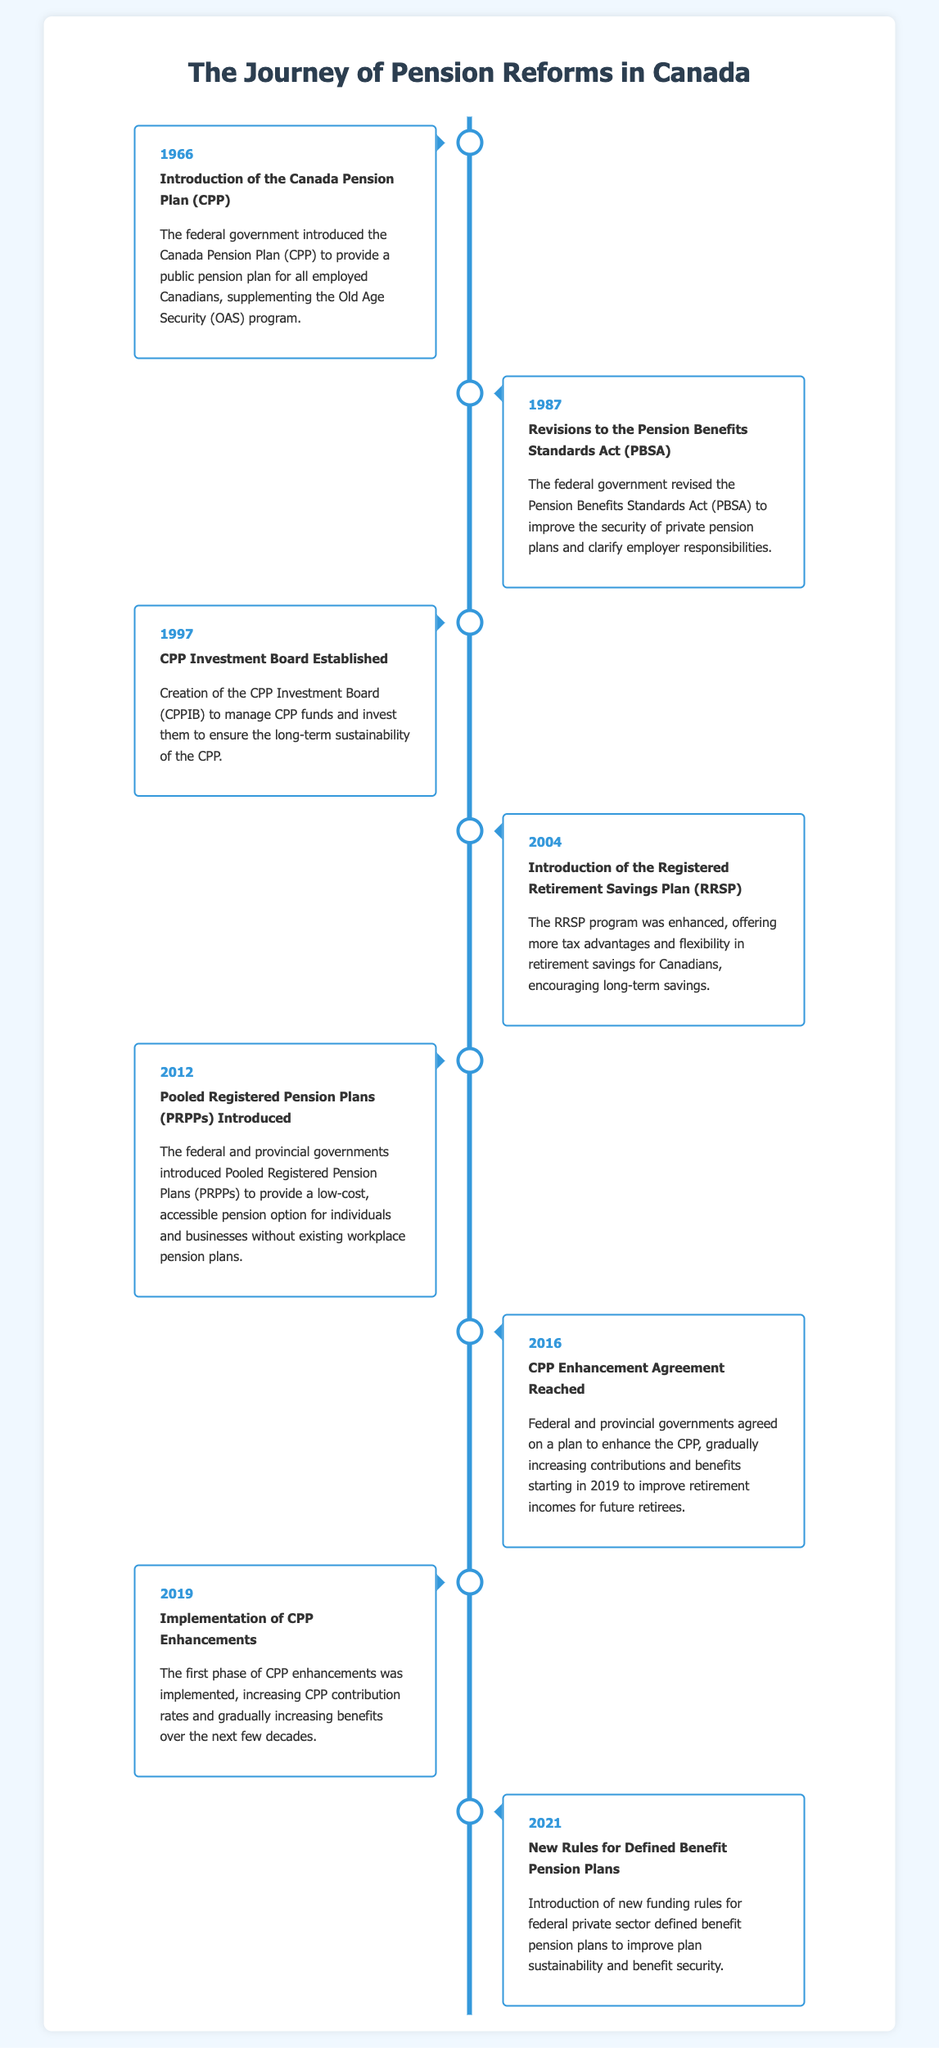What year was the Canada Pension Plan introduced? The introduction of the Canada Pension Plan (CPP) is specifically noted in the document as 1966.
Answer: 1966 What major change occurred in 2016 regarding the Canada Pension Plan? In 2016, an agreement was reached to enhance the CPP, which included increasing contributions and benefits.
Answer: CPP Enhancement Agreement What does RRSP stand for? The document mentions the introduction of the Registered Retirement Savings Plan (RRSP) in 2004.
Answer: RRSP What organization was established in 1997 to manage CPP funds? The CPP Investment Board (CPPIB) was created in 1997 as noted in the document.
Answer: CPP Investment Board How many years apart were the introduction of the CPP and the PRPPs? The CPP was introduced in 1966 and PRPPs were introduced in 2012, which are 46 years apart.
Answer: 46 What is the main purpose of Pooled Registered Pension Plans (PRPPs)? PRPPs were introduced to provide a low-cost, accessible pension option for individuals and businesses without existing workplace pension plans.
Answer: Low-cost, accessible pension option What year saw the implementation of CPP enhancements? The first phase of CPP enhancements was implemented in 2019 as stated in the document.
Answer: 2019 What significant legislative change occurred in 2021? In 2021, new rules for defined benefit pension plans were introduced to improve sustainability and security.
Answer: New funding rules 